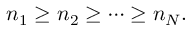Convert formula to latex. <formula><loc_0><loc_0><loc_500><loc_500>n _ { 1 } \geq n _ { 2 } \geq \cdots \geq n _ { N } .</formula> 